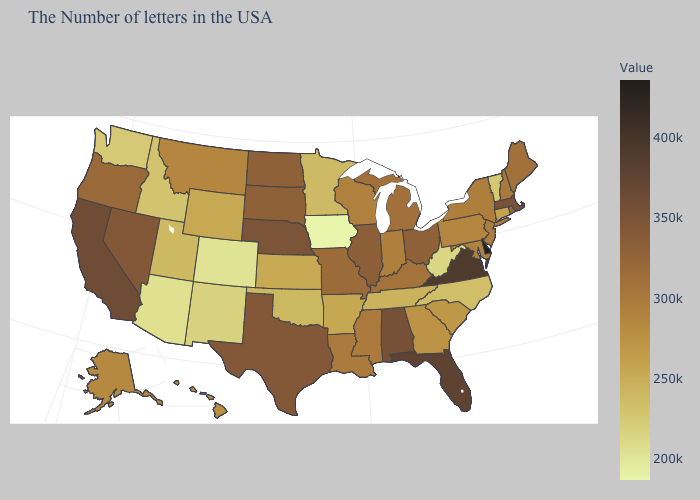Does Arizona have the highest value in the West?
Be succinct. No. Among the states that border Virginia , which have the lowest value?
Be succinct. West Virginia. Does Illinois have a lower value than Florida?
Be succinct. Yes. Is the legend a continuous bar?
Write a very short answer. Yes. Does West Virginia have the lowest value in the South?
Keep it brief. Yes. Does Maine have a lower value than Tennessee?
Be succinct. No. Which states hav the highest value in the Northeast?
Be succinct. Massachusetts. Does Virginia have the highest value in the South?
Write a very short answer. No. Which states have the lowest value in the South?
Be succinct. West Virginia. 